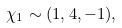<formula> <loc_0><loc_0><loc_500><loc_500>\chi _ { 1 } \sim ( 1 , 4 , - 1 ) ,</formula> 